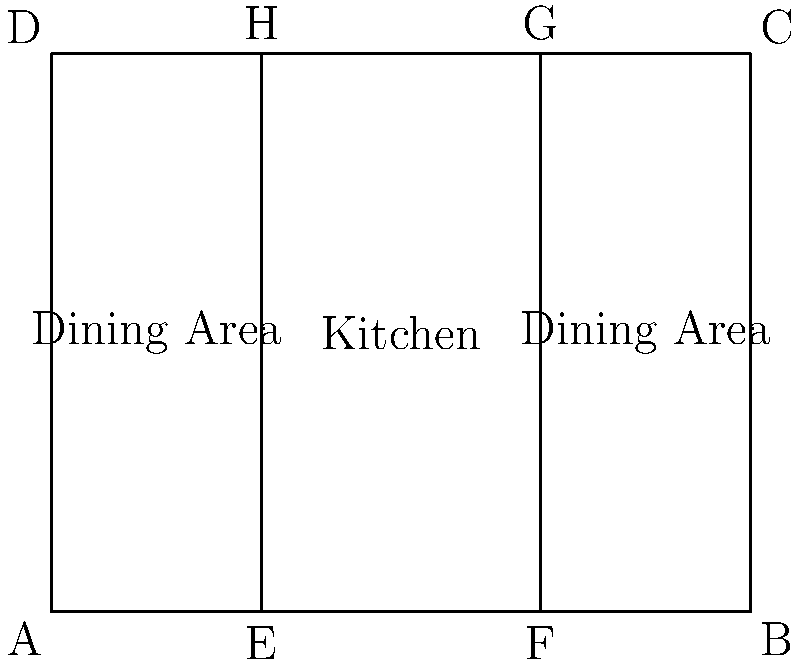In designing a modular restaurant layout for your fast-casual chain, you've created a rectangular floor plan with a central kitchen area and flexible dining spaces on either side. The restaurant has a width of $w$ and a length of $l$. The kitchen area is represented by rectangle EFGH, with EF = $0.4w$ and EH = $l$. What is the total area of the two dining spaces combined in terms of $w$ and $l$? To find the total area of the two dining spaces, we need to follow these steps:

1. Calculate the total area of the restaurant:
   Total area = $w \times l$

2. Calculate the area of the kitchen:
   Kitchen area = $0.4w \times l$

3. Subtract the kitchen area from the total area to get the dining area:
   Dining area = Total area - Kitchen area
                = $(w \times l) - (0.4w \times l)$
                = $wl - 0.4wl$
                = $0.6wl$

Therefore, the total area of the two dining spaces combined is $0.6wl$.
Answer: $0.6wl$ 